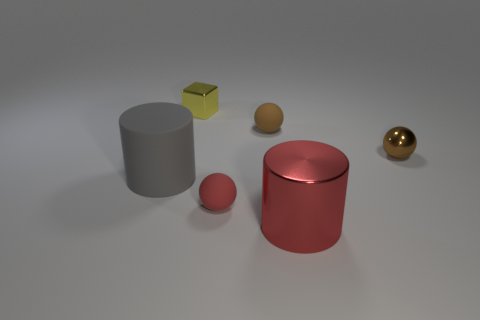Subtract all tiny red matte balls. How many balls are left? 2 Add 1 red matte objects. How many objects exist? 7 Subtract all red cylinders. How many cylinders are left? 1 Subtract all cylinders. How many objects are left? 4 Subtract 2 cylinders. How many cylinders are left? 0 Subtract all cyan spheres. Subtract all green cubes. How many spheres are left? 3 Subtract all purple cylinders. How many cyan balls are left? 0 Subtract all metal objects. Subtract all cylinders. How many objects are left? 1 Add 1 tiny blocks. How many tiny blocks are left? 2 Add 1 shiny objects. How many shiny objects exist? 4 